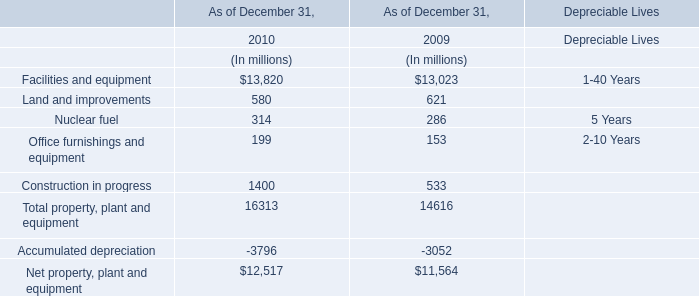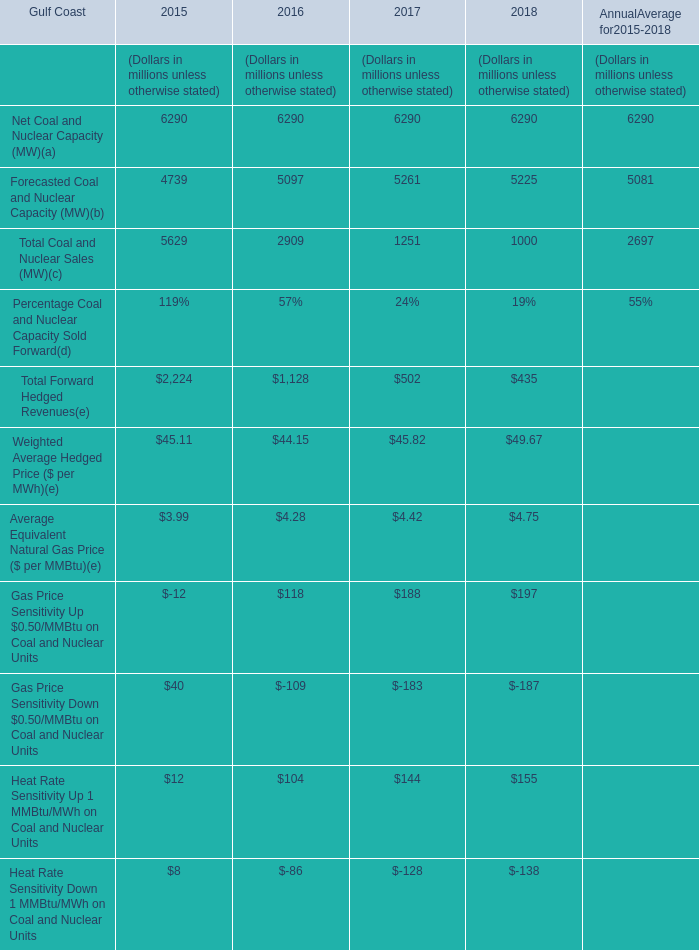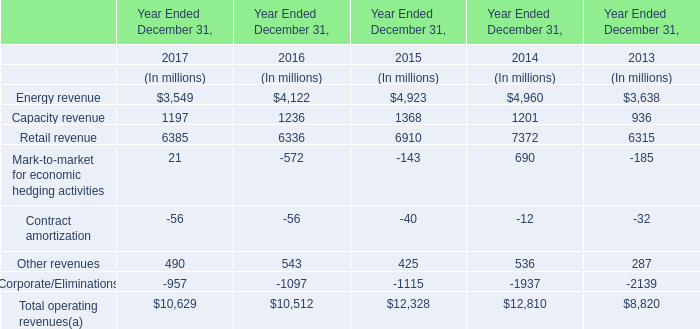What was the total amount of elements greater than 4000 in 2015? (in million) 
Computations: ((6290 + 4739) + 5629)
Answer: 16658.0. 